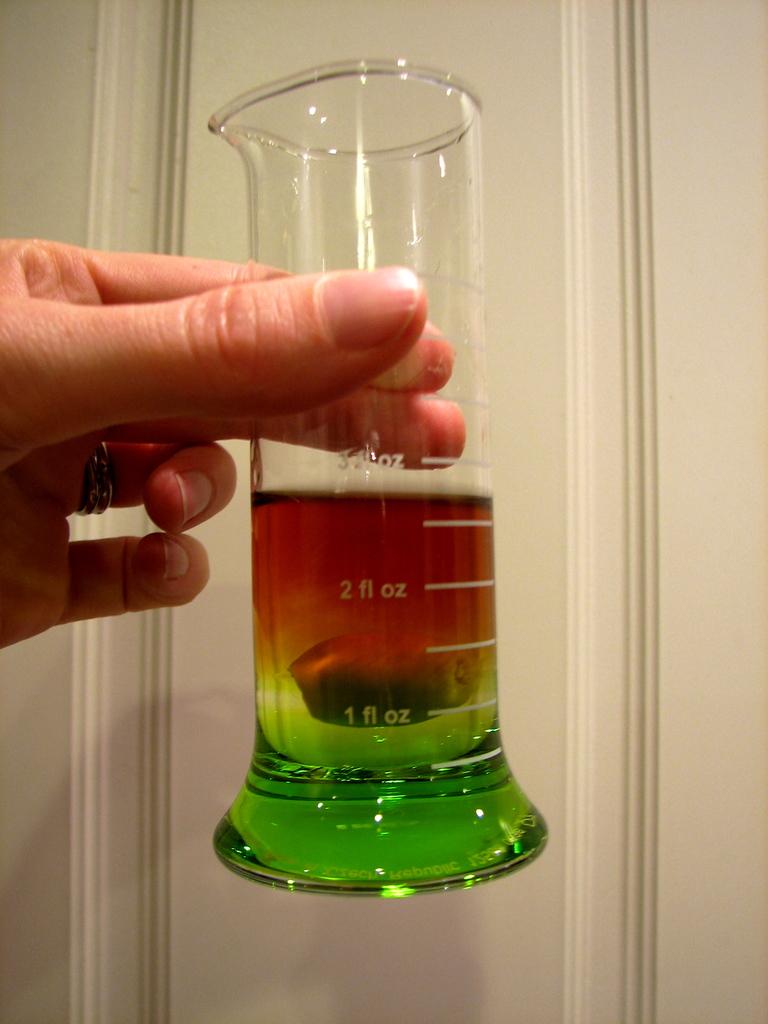This shot is almost how many ounces?
Give a very brief answer. 3. 